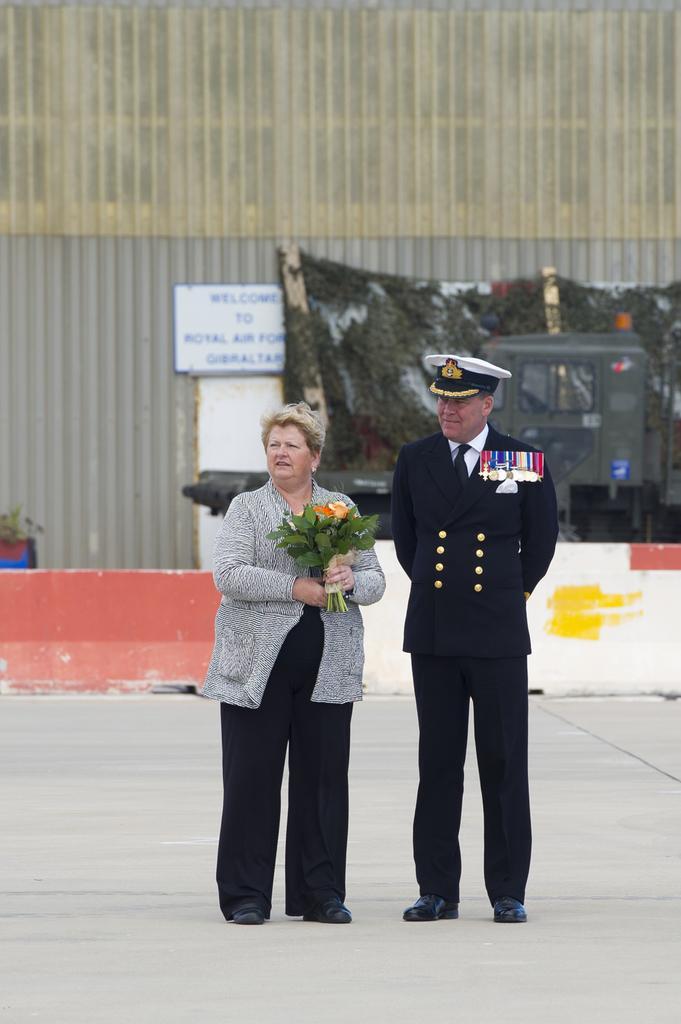Please provide a concise description of this image. This is the man and woman standing. This woman is holding a flower bouquet in her hands. This looks like a building wall. I can see a board, which is attached to the wall. I think this is a road divider. This looks like a vehicle. 